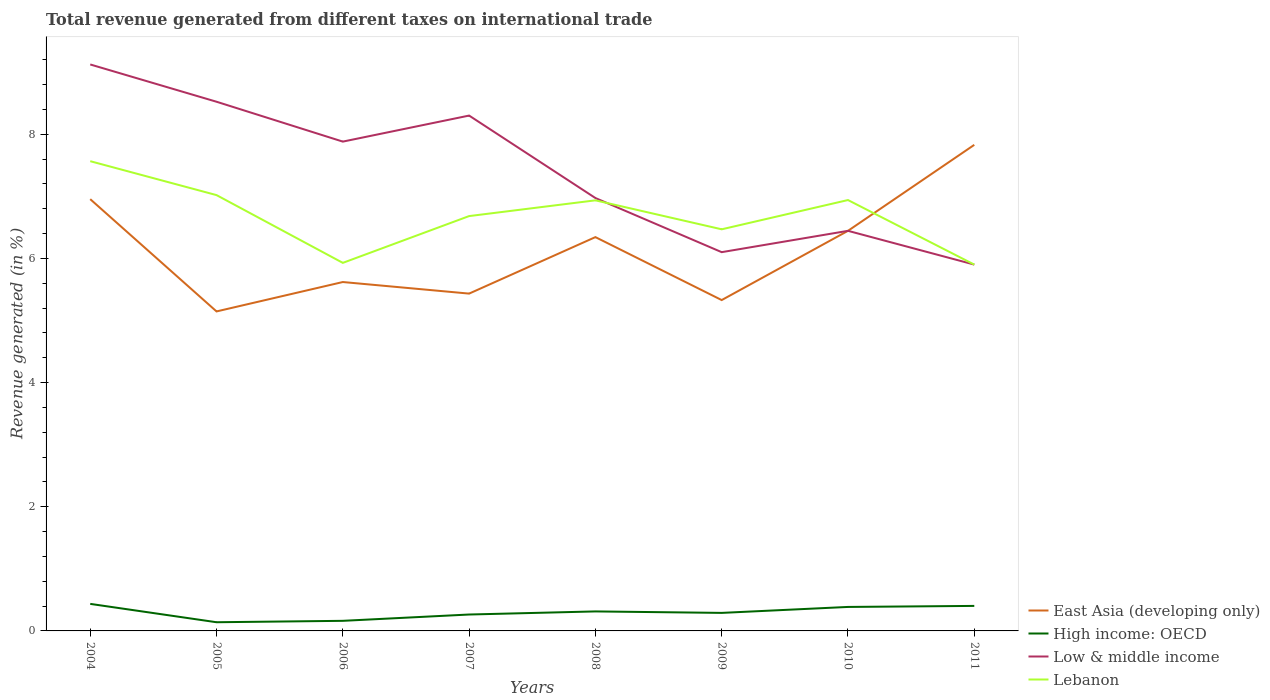How many different coloured lines are there?
Provide a succinct answer. 4. Does the line corresponding to East Asia (developing only) intersect with the line corresponding to Lebanon?
Provide a succinct answer. Yes. Is the number of lines equal to the number of legend labels?
Your response must be concise. Yes. Across all years, what is the maximum total revenue generated in High income: OECD?
Offer a very short reply. 0.14. In which year was the total revenue generated in Lebanon maximum?
Give a very brief answer. 2011. What is the total total revenue generated in Low & middle income in the graph?
Ensure brevity in your answer.  1.78. What is the difference between the highest and the second highest total revenue generated in Low & middle income?
Give a very brief answer. 3.22. What is the difference between the highest and the lowest total revenue generated in Low & middle income?
Keep it short and to the point. 4. Is the total revenue generated in Lebanon strictly greater than the total revenue generated in Low & middle income over the years?
Provide a succinct answer. No. What is the difference between two consecutive major ticks on the Y-axis?
Your answer should be compact. 2. Are the values on the major ticks of Y-axis written in scientific E-notation?
Give a very brief answer. No. Does the graph contain any zero values?
Offer a terse response. No. Does the graph contain grids?
Give a very brief answer. No. How many legend labels are there?
Your answer should be very brief. 4. What is the title of the graph?
Keep it short and to the point. Total revenue generated from different taxes on international trade. Does "Saudi Arabia" appear as one of the legend labels in the graph?
Give a very brief answer. No. What is the label or title of the X-axis?
Provide a short and direct response. Years. What is the label or title of the Y-axis?
Provide a succinct answer. Revenue generated (in %). What is the Revenue generated (in %) of East Asia (developing only) in 2004?
Offer a very short reply. 6.95. What is the Revenue generated (in %) of High income: OECD in 2004?
Ensure brevity in your answer.  0.44. What is the Revenue generated (in %) of Low & middle income in 2004?
Provide a succinct answer. 9.12. What is the Revenue generated (in %) in Lebanon in 2004?
Give a very brief answer. 7.57. What is the Revenue generated (in %) in East Asia (developing only) in 2005?
Provide a succinct answer. 5.15. What is the Revenue generated (in %) in High income: OECD in 2005?
Offer a very short reply. 0.14. What is the Revenue generated (in %) of Low & middle income in 2005?
Your response must be concise. 8.52. What is the Revenue generated (in %) of Lebanon in 2005?
Ensure brevity in your answer.  7.02. What is the Revenue generated (in %) of East Asia (developing only) in 2006?
Offer a terse response. 5.62. What is the Revenue generated (in %) in High income: OECD in 2006?
Give a very brief answer. 0.16. What is the Revenue generated (in %) in Low & middle income in 2006?
Keep it short and to the point. 7.88. What is the Revenue generated (in %) in Lebanon in 2006?
Offer a terse response. 5.93. What is the Revenue generated (in %) in East Asia (developing only) in 2007?
Offer a very short reply. 5.43. What is the Revenue generated (in %) of High income: OECD in 2007?
Offer a terse response. 0.26. What is the Revenue generated (in %) in Low & middle income in 2007?
Your answer should be compact. 8.3. What is the Revenue generated (in %) of Lebanon in 2007?
Keep it short and to the point. 6.68. What is the Revenue generated (in %) in East Asia (developing only) in 2008?
Your answer should be very brief. 6.34. What is the Revenue generated (in %) of High income: OECD in 2008?
Your response must be concise. 0.31. What is the Revenue generated (in %) in Low & middle income in 2008?
Provide a short and direct response. 6.97. What is the Revenue generated (in %) of Lebanon in 2008?
Ensure brevity in your answer.  6.93. What is the Revenue generated (in %) in East Asia (developing only) in 2009?
Ensure brevity in your answer.  5.33. What is the Revenue generated (in %) of High income: OECD in 2009?
Offer a very short reply. 0.29. What is the Revenue generated (in %) of Low & middle income in 2009?
Make the answer very short. 6.1. What is the Revenue generated (in %) in Lebanon in 2009?
Provide a succinct answer. 6.47. What is the Revenue generated (in %) of East Asia (developing only) in 2010?
Your answer should be compact. 6.44. What is the Revenue generated (in %) of High income: OECD in 2010?
Provide a succinct answer. 0.39. What is the Revenue generated (in %) in Low & middle income in 2010?
Offer a very short reply. 6.44. What is the Revenue generated (in %) of Lebanon in 2010?
Offer a terse response. 6.94. What is the Revenue generated (in %) in East Asia (developing only) in 2011?
Make the answer very short. 7.83. What is the Revenue generated (in %) in High income: OECD in 2011?
Offer a very short reply. 0.4. What is the Revenue generated (in %) in Low & middle income in 2011?
Your answer should be very brief. 5.9. What is the Revenue generated (in %) in Lebanon in 2011?
Provide a short and direct response. 5.9. Across all years, what is the maximum Revenue generated (in %) of East Asia (developing only)?
Your response must be concise. 7.83. Across all years, what is the maximum Revenue generated (in %) in High income: OECD?
Make the answer very short. 0.44. Across all years, what is the maximum Revenue generated (in %) in Low & middle income?
Your answer should be compact. 9.12. Across all years, what is the maximum Revenue generated (in %) in Lebanon?
Your response must be concise. 7.57. Across all years, what is the minimum Revenue generated (in %) of East Asia (developing only)?
Keep it short and to the point. 5.15. Across all years, what is the minimum Revenue generated (in %) in High income: OECD?
Ensure brevity in your answer.  0.14. Across all years, what is the minimum Revenue generated (in %) in Low & middle income?
Provide a succinct answer. 5.9. Across all years, what is the minimum Revenue generated (in %) of Lebanon?
Give a very brief answer. 5.9. What is the total Revenue generated (in %) in East Asia (developing only) in the graph?
Make the answer very short. 49.09. What is the total Revenue generated (in %) in High income: OECD in the graph?
Ensure brevity in your answer.  2.4. What is the total Revenue generated (in %) in Low & middle income in the graph?
Keep it short and to the point. 59.24. What is the total Revenue generated (in %) of Lebanon in the graph?
Give a very brief answer. 53.44. What is the difference between the Revenue generated (in %) of East Asia (developing only) in 2004 and that in 2005?
Give a very brief answer. 1.81. What is the difference between the Revenue generated (in %) in High income: OECD in 2004 and that in 2005?
Ensure brevity in your answer.  0.3. What is the difference between the Revenue generated (in %) of Low & middle income in 2004 and that in 2005?
Keep it short and to the point. 0.6. What is the difference between the Revenue generated (in %) of Lebanon in 2004 and that in 2005?
Offer a terse response. 0.55. What is the difference between the Revenue generated (in %) of East Asia (developing only) in 2004 and that in 2006?
Your answer should be very brief. 1.33. What is the difference between the Revenue generated (in %) of High income: OECD in 2004 and that in 2006?
Ensure brevity in your answer.  0.27. What is the difference between the Revenue generated (in %) of Low & middle income in 2004 and that in 2006?
Offer a very short reply. 1.24. What is the difference between the Revenue generated (in %) of Lebanon in 2004 and that in 2006?
Keep it short and to the point. 1.64. What is the difference between the Revenue generated (in %) in East Asia (developing only) in 2004 and that in 2007?
Provide a succinct answer. 1.52. What is the difference between the Revenue generated (in %) of High income: OECD in 2004 and that in 2007?
Provide a short and direct response. 0.17. What is the difference between the Revenue generated (in %) in Low & middle income in 2004 and that in 2007?
Your answer should be very brief. 0.82. What is the difference between the Revenue generated (in %) in Lebanon in 2004 and that in 2007?
Your response must be concise. 0.88. What is the difference between the Revenue generated (in %) of East Asia (developing only) in 2004 and that in 2008?
Ensure brevity in your answer.  0.61. What is the difference between the Revenue generated (in %) in High income: OECD in 2004 and that in 2008?
Keep it short and to the point. 0.12. What is the difference between the Revenue generated (in %) in Low & middle income in 2004 and that in 2008?
Give a very brief answer. 2.15. What is the difference between the Revenue generated (in %) of Lebanon in 2004 and that in 2008?
Your answer should be very brief. 0.63. What is the difference between the Revenue generated (in %) in East Asia (developing only) in 2004 and that in 2009?
Give a very brief answer. 1.63. What is the difference between the Revenue generated (in %) of High income: OECD in 2004 and that in 2009?
Provide a short and direct response. 0.15. What is the difference between the Revenue generated (in %) of Low & middle income in 2004 and that in 2009?
Your answer should be very brief. 3.02. What is the difference between the Revenue generated (in %) of Lebanon in 2004 and that in 2009?
Provide a succinct answer. 1.1. What is the difference between the Revenue generated (in %) in East Asia (developing only) in 2004 and that in 2010?
Your response must be concise. 0.51. What is the difference between the Revenue generated (in %) of High income: OECD in 2004 and that in 2010?
Provide a succinct answer. 0.05. What is the difference between the Revenue generated (in %) in Low & middle income in 2004 and that in 2010?
Offer a very short reply. 2.68. What is the difference between the Revenue generated (in %) in Lebanon in 2004 and that in 2010?
Your answer should be compact. 0.63. What is the difference between the Revenue generated (in %) in East Asia (developing only) in 2004 and that in 2011?
Offer a terse response. -0.87. What is the difference between the Revenue generated (in %) of High income: OECD in 2004 and that in 2011?
Your answer should be compact. 0.03. What is the difference between the Revenue generated (in %) of Low & middle income in 2004 and that in 2011?
Your answer should be compact. 3.22. What is the difference between the Revenue generated (in %) in Lebanon in 2004 and that in 2011?
Your answer should be very brief. 1.67. What is the difference between the Revenue generated (in %) of East Asia (developing only) in 2005 and that in 2006?
Your response must be concise. -0.47. What is the difference between the Revenue generated (in %) of High income: OECD in 2005 and that in 2006?
Provide a succinct answer. -0.02. What is the difference between the Revenue generated (in %) of Low & middle income in 2005 and that in 2006?
Make the answer very short. 0.64. What is the difference between the Revenue generated (in %) in Lebanon in 2005 and that in 2006?
Give a very brief answer. 1.09. What is the difference between the Revenue generated (in %) of East Asia (developing only) in 2005 and that in 2007?
Offer a terse response. -0.29. What is the difference between the Revenue generated (in %) in High income: OECD in 2005 and that in 2007?
Keep it short and to the point. -0.12. What is the difference between the Revenue generated (in %) in Low & middle income in 2005 and that in 2007?
Ensure brevity in your answer.  0.22. What is the difference between the Revenue generated (in %) in Lebanon in 2005 and that in 2007?
Offer a very short reply. 0.34. What is the difference between the Revenue generated (in %) in East Asia (developing only) in 2005 and that in 2008?
Make the answer very short. -1.2. What is the difference between the Revenue generated (in %) of High income: OECD in 2005 and that in 2008?
Offer a terse response. -0.17. What is the difference between the Revenue generated (in %) of Low & middle income in 2005 and that in 2008?
Offer a very short reply. 1.55. What is the difference between the Revenue generated (in %) of Lebanon in 2005 and that in 2008?
Give a very brief answer. 0.08. What is the difference between the Revenue generated (in %) of East Asia (developing only) in 2005 and that in 2009?
Ensure brevity in your answer.  -0.18. What is the difference between the Revenue generated (in %) of High income: OECD in 2005 and that in 2009?
Ensure brevity in your answer.  -0.15. What is the difference between the Revenue generated (in %) of Low & middle income in 2005 and that in 2009?
Give a very brief answer. 2.42. What is the difference between the Revenue generated (in %) of Lebanon in 2005 and that in 2009?
Offer a very short reply. 0.55. What is the difference between the Revenue generated (in %) in East Asia (developing only) in 2005 and that in 2010?
Provide a short and direct response. -1.3. What is the difference between the Revenue generated (in %) of High income: OECD in 2005 and that in 2010?
Keep it short and to the point. -0.25. What is the difference between the Revenue generated (in %) of Low & middle income in 2005 and that in 2010?
Your answer should be compact. 2.08. What is the difference between the Revenue generated (in %) of Lebanon in 2005 and that in 2010?
Provide a succinct answer. 0.08. What is the difference between the Revenue generated (in %) in East Asia (developing only) in 2005 and that in 2011?
Ensure brevity in your answer.  -2.68. What is the difference between the Revenue generated (in %) in High income: OECD in 2005 and that in 2011?
Keep it short and to the point. -0.26. What is the difference between the Revenue generated (in %) in Low & middle income in 2005 and that in 2011?
Provide a succinct answer. 2.62. What is the difference between the Revenue generated (in %) in Lebanon in 2005 and that in 2011?
Give a very brief answer. 1.12. What is the difference between the Revenue generated (in %) of East Asia (developing only) in 2006 and that in 2007?
Give a very brief answer. 0.19. What is the difference between the Revenue generated (in %) in High income: OECD in 2006 and that in 2007?
Give a very brief answer. -0.1. What is the difference between the Revenue generated (in %) of Low & middle income in 2006 and that in 2007?
Offer a very short reply. -0.42. What is the difference between the Revenue generated (in %) in Lebanon in 2006 and that in 2007?
Provide a short and direct response. -0.75. What is the difference between the Revenue generated (in %) in East Asia (developing only) in 2006 and that in 2008?
Ensure brevity in your answer.  -0.72. What is the difference between the Revenue generated (in %) in High income: OECD in 2006 and that in 2008?
Offer a very short reply. -0.15. What is the difference between the Revenue generated (in %) in Low & middle income in 2006 and that in 2008?
Keep it short and to the point. 0.91. What is the difference between the Revenue generated (in %) of Lebanon in 2006 and that in 2008?
Keep it short and to the point. -1.01. What is the difference between the Revenue generated (in %) of East Asia (developing only) in 2006 and that in 2009?
Your answer should be compact. 0.29. What is the difference between the Revenue generated (in %) in High income: OECD in 2006 and that in 2009?
Ensure brevity in your answer.  -0.13. What is the difference between the Revenue generated (in %) of Low & middle income in 2006 and that in 2009?
Your answer should be compact. 1.78. What is the difference between the Revenue generated (in %) of Lebanon in 2006 and that in 2009?
Give a very brief answer. -0.54. What is the difference between the Revenue generated (in %) in East Asia (developing only) in 2006 and that in 2010?
Ensure brevity in your answer.  -0.82. What is the difference between the Revenue generated (in %) in High income: OECD in 2006 and that in 2010?
Offer a very short reply. -0.22. What is the difference between the Revenue generated (in %) of Low & middle income in 2006 and that in 2010?
Your answer should be very brief. 1.44. What is the difference between the Revenue generated (in %) in Lebanon in 2006 and that in 2010?
Your answer should be very brief. -1.01. What is the difference between the Revenue generated (in %) in East Asia (developing only) in 2006 and that in 2011?
Your response must be concise. -2.21. What is the difference between the Revenue generated (in %) of High income: OECD in 2006 and that in 2011?
Keep it short and to the point. -0.24. What is the difference between the Revenue generated (in %) in Low & middle income in 2006 and that in 2011?
Your response must be concise. 1.98. What is the difference between the Revenue generated (in %) of Lebanon in 2006 and that in 2011?
Offer a very short reply. 0.03. What is the difference between the Revenue generated (in %) in East Asia (developing only) in 2007 and that in 2008?
Your response must be concise. -0.91. What is the difference between the Revenue generated (in %) of High income: OECD in 2007 and that in 2008?
Your answer should be very brief. -0.05. What is the difference between the Revenue generated (in %) of Low & middle income in 2007 and that in 2008?
Your answer should be compact. 1.33. What is the difference between the Revenue generated (in %) of Lebanon in 2007 and that in 2008?
Offer a very short reply. -0.25. What is the difference between the Revenue generated (in %) in East Asia (developing only) in 2007 and that in 2009?
Give a very brief answer. 0.1. What is the difference between the Revenue generated (in %) of High income: OECD in 2007 and that in 2009?
Provide a succinct answer. -0.03. What is the difference between the Revenue generated (in %) in Lebanon in 2007 and that in 2009?
Your response must be concise. 0.21. What is the difference between the Revenue generated (in %) in East Asia (developing only) in 2007 and that in 2010?
Offer a terse response. -1.01. What is the difference between the Revenue generated (in %) in High income: OECD in 2007 and that in 2010?
Provide a succinct answer. -0.12. What is the difference between the Revenue generated (in %) of Low & middle income in 2007 and that in 2010?
Offer a terse response. 1.86. What is the difference between the Revenue generated (in %) of Lebanon in 2007 and that in 2010?
Ensure brevity in your answer.  -0.26. What is the difference between the Revenue generated (in %) of East Asia (developing only) in 2007 and that in 2011?
Offer a terse response. -2.4. What is the difference between the Revenue generated (in %) in High income: OECD in 2007 and that in 2011?
Provide a succinct answer. -0.14. What is the difference between the Revenue generated (in %) in Low & middle income in 2007 and that in 2011?
Ensure brevity in your answer.  2.4. What is the difference between the Revenue generated (in %) of Lebanon in 2007 and that in 2011?
Offer a terse response. 0.78. What is the difference between the Revenue generated (in %) in High income: OECD in 2008 and that in 2009?
Your answer should be compact. 0.02. What is the difference between the Revenue generated (in %) in Low & middle income in 2008 and that in 2009?
Offer a very short reply. 0.87. What is the difference between the Revenue generated (in %) in Lebanon in 2008 and that in 2009?
Give a very brief answer. 0.47. What is the difference between the Revenue generated (in %) of East Asia (developing only) in 2008 and that in 2010?
Offer a terse response. -0.1. What is the difference between the Revenue generated (in %) of High income: OECD in 2008 and that in 2010?
Give a very brief answer. -0.07. What is the difference between the Revenue generated (in %) in Low & middle income in 2008 and that in 2010?
Keep it short and to the point. 0.53. What is the difference between the Revenue generated (in %) in Lebanon in 2008 and that in 2010?
Make the answer very short. -0. What is the difference between the Revenue generated (in %) in East Asia (developing only) in 2008 and that in 2011?
Your response must be concise. -1.49. What is the difference between the Revenue generated (in %) of High income: OECD in 2008 and that in 2011?
Your response must be concise. -0.09. What is the difference between the Revenue generated (in %) in Low & middle income in 2008 and that in 2011?
Provide a short and direct response. 1.07. What is the difference between the Revenue generated (in %) in Lebanon in 2008 and that in 2011?
Provide a succinct answer. 1.03. What is the difference between the Revenue generated (in %) of East Asia (developing only) in 2009 and that in 2010?
Make the answer very short. -1.12. What is the difference between the Revenue generated (in %) in High income: OECD in 2009 and that in 2010?
Provide a succinct answer. -0.1. What is the difference between the Revenue generated (in %) of Low & middle income in 2009 and that in 2010?
Your answer should be compact. -0.34. What is the difference between the Revenue generated (in %) in Lebanon in 2009 and that in 2010?
Ensure brevity in your answer.  -0.47. What is the difference between the Revenue generated (in %) in High income: OECD in 2009 and that in 2011?
Your answer should be compact. -0.11. What is the difference between the Revenue generated (in %) of Low & middle income in 2009 and that in 2011?
Your answer should be compact. 0.2. What is the difference between the Revenue generated (in %) in Lebanon in 2009 and that in 2011?
Your answer should be very brief. 0.57. What is the difference between the Revenue generated (in %) in East Asia (developing only) in 2010 and that in 2011?
Give a very brief answer. -1.38. What is the difference between the Revenue generated (in %) of High income: OECD in 2010 and that in 2011?
Give a very brief answer. -0.02. What is the difference between the Revenue generated (in %) in Low & middle income in 2010 and that in 2011?
Give a very brief answer. 0.54. What is the difference between the Revenue generated (in %) in Lebanon in 2010 and that in 2011?
Your answer should be very brief. 1.04. What is the difference between the Revenue generated (in %) in East Asia (developing only) in 2004 and the Revenue generated (in %) in High income: OECD in 2005?
Make the answer very short. 6.81. What is the difference between the Revenue generated (in %) of East Asia (developing only) in 2004 and the Revenue generated (in %) of Low & middle income in 2005?
Ensure brevity in your answer.  -1.57. What is the difference between the Revenue generated (in %) in East Asia (developing only) in 2004 and the Revenue generated (in %) in Lebanon in 2005?
Make the answer very short. -0.07. What is the difference between the Revenue generated (in %) of High income: OECD in 2004 and the Revenue generated (in %) of Low & middle income in 2005?
Your response must be concise. -8.09. What is the difference between the Revenue generated (in %) of High income: OECD in 2004 and the Revenue generated (in %) of Lebanon in 2005?
Offer a terse response. -6.58. What is the difference between the Revenue generated (in %) in Low & middle income in 2004 and the Revenue generated (in %) in Lebanon in 2005?
Your response must be concise. 2.1. What is the difference between the Revenue generated (in %) in East Asia (developing only) in 2004 and the Revenue generated (in %) in High income: OECD in 2006?
Provide a short and direct response. 6.79. What is the difference between the Revenue generated (in %) in East Asia (developing only) in 2004 and the Revenue generated (in %) in Low & middle income in 2006?
Your answer should be very brief. -0.93. What is the difference between the Revenue generated (in %) in East Asia (developing only) in 2004 and the Revenue generated (in %) in Lebanon in 2006?
Provide a short and direct response. 1.03. What is the difference between the Revenue generated (in %) in High income: OECD in 2004 and the Revenue generated (in %) in Low & middle income in 2006?
Offer a very short reply. -7.45. What is the difference between the Revenue generated (in %) of High income: OECD in 2004 and the Revenue generated (in %) of Lebanon in 2006?
Ensure brevity in your answer.  -5.49. What is the difference between the Revenue generated (in %) in Low & middle income in 2004 and the Revenue generated (in %) in Lebanon in 2006?
Your answer should be very brief. 3.2. What is the difference between the Revenue generated (in %) in East Asia (developing only) in 2004 and the Revenue generated (in %) in High income: OECD in 2007?
Provide a short and direct response. 6.69. What is the difference between the Revenue generated (in %) in East Asia (developing only) in 2004 and the Revenue generated (in %) in Low & middle income in 2007?
Provide a succinct answer. -1.35. What is the difference between the Revenue generated (in %) in East Asia (developing only) in 2004 and the Revenue generated (in %) in Lebanon in 2007?
Provide a short and direct response. 0.27. What is the difference between the Revenue generated (in %) of High income: OECD in 2004 and the Revenue generated (in %) of Low & middle income in 2007?
Give a very brief answer. -7.86. What is the difference between the Revenue generated (in %) in High income: OECD in 2004 and the Revenue generated (in %) in Lebanon in 2007?
Your answer should be compact. -6.25. What is the difference between the Revenue generated (in %) of Low & middle income in 2004 and the Revenue generated (in %) of Lebanon in 2007?
Your answer should be very brief. 2.44. What is the difference between the Revenue generated (in %) of East Asia (developing only) in 2004 and the Revenue generated (in %) of High income: OECD in 2008?
Provide a short and direct response. 6.64. What is the difference between the Revenue generated (in %) of East Asia (developing only) in 2004 and the Revenue generated (in %) of Low & middle income in 2008?
Make the answer very short. -0.02. What is the difference between the Revenue generated (in %) of East Asia (developing only) in 2004 and the Revenue generated (in %) of Lebanon in 2008?
Your answer should be compact. 0.02. What is the difference between the Revenue generated (in %) of High income: OECD in 2004 and the Revenue generated (in %) of Low & middle income in 2008?
Keep it short and to the point. -6.54. What is the difference between the Revenue generated (in %) of High income: OECD in 2004 and the Revenue generated (in %) of Lebanon in 2008?
Give a very brief answer. -6.5. What is the difference between the Revenue generated (in %) of Low & middle income in 2004 and the Revenue generated (in %) of Lebanon in 2008?
Ensure brevity in your answer.  2.19. What is the difference between the Revenue generated (in %) of East Asia (developing only) in 2004 and the Revenue generated (in %) of High income: OECD in 2009?
Your answer should be compact. 6.66. What is the difference between the Revenue generated (in %) in East Asia (developing only) in 2004 and the Revenue generated (in %) in Low & middle income in 2009?
Provide a short and direct response. 0.85. What is the difference between the Revenue generated (in %) in East Asia (developing only) in 2004 and the Revenue generated (in %) in Lebanon in 2009?
Your answer should be compact. 0.49. What is the difference between the Revenue generated (in %) of High income: OECD in 2004 and the Revenue generated (in %) of Low & middle income in 2009?
Your response must be concise. -5.66. What is the difference between the Revenue generated (in %) in High income: OECD in 2004 and the Revenue generated (in %) in Lebanon in 2009?
Ensure brevity in your answer.  -6.03. What is the difference between the Revenue generated (in %) of Low & middle income in 2004 and the Revenue generated (in %) of Lebanon in 2009?
Offer a terse response. 2.65. What is the difference between the Revenue generated (in %) of East Asia (developing only) in 2004 and the Revenue generated (in %) of High income: OECD in 2010?
Ensure brevity in your answer.  6.57. What is the difference between the Revenue generated (in %) of East Asia (developing only) in 2004 and the Revenue generated (in %) of Low & middle income in 2010?
Ensure brevity in your answer.  0.51. What is the difference between the Revenue generated (in %) of East Asia (developing only) in 2004 and the Revenue generated (in %) of Lebanon in 2010?
Give a very brief answer. 0.01. What is the difference between the Revenue generated (in %) of High income: OECD in 2004 and the Revenue generated (in %) of Low & middle income in 2010?
Provide a succinct answer. -6.01. What is the difference between the Revenue generated (in %) in High income: OECD in 2004 and the Revenue generated (in %) in Lebanon in 2010?
Give a very brief answer. -6.5. What is the difference between the Revenue generated (in %) of Low & middle income in 2004 and the Revenue generated (in %) of Lebanon in 2010?
Keep it short and to the point. 2.18. What is the difference between the Revenue generated (in %) in East Asia (developing only) in 2004 and the Revenue generated (in %) in High income: OECD in 2011?
Offer a terse response. 6.55. What is the difference between the Revenue generated (in %) in East Asia (developing only) in 2004 and the Revenue generated (in %) in Low & middle income in 2011?
Offer a terse response. 1.05. What is the difference between the Revenue generated (in %) in East Asia (developing only) in 2004 and the Revenue generated (in %) in Lebanon in 2011?
Ensure brevity in your answer.  1.05. What is the difference between the Revenue generated (in %) in High income: OECD in 2004 and the Revenue generated (in %) in Low & middle income in 2011?
Provide a succinct answer. -5.46. What is the difference between the Revenue generated (in %) of High income: OECD in 2004 and the Revenue generated (in %) of Lebanon in 2011?
Keep it short and to the point. -5.46. What is the difference between the Revenue generated (in %) of Low & middle income in 2004 and the Revenue generated (in %) of Lebanon in 2011?
Offer a very short reply. 3.22. What is the difference between the Revenue generated (in %) in East Asia (developing only) in 2005 and the Revenue generated (in %) in High income: OECD in 2006?
Provide a short and direct response. 4.98. What is the difference between the Revenue generated (in %) in East Asia (developing only) in 2005 and the Revenue generated (in %) in Low & middle income in 2006?
Provide a short and direct response. -2.73. What is the difference between the Revenue generated (in %) in East Asia (developing only) in 2005 and the Revenue generated (in %) in Lebanon in 2006?
Keep it short and to the point. -0.78. What is the difference between the Revenue generated (in %) of High income: OECD in 2005 and the Revenue generated (in %) of Low & middle income in 2006?
Offer a very short reply. -7.74. What is the difference between the Revenue generated (in %) of High income: OECD in 2005 and the Revenue generated (in %) of Lebanon in 2006?
Make the answer very short. -5.79. What is the difference between the Revenue generated (in %) in Low & middle income in 2005 and the Revenue generated (in %) in Lebanon in 2006?
Provide a succinct answer. 2.6. What is the difference between the Revenue generated (in %) in East Asia (developing only) in 2005 and the Revenue generated (in %) in High income: OECD in 2007?
Your answer should be very brief. 4.88. What is the difference between the Revenue generated (in %) in East Asia (developing only) in 2005 and the Revenue generated (in %) in Low & middle income in 2007?
Offer a terse response. -3.15. What is the difference between the Revenue generated (in %) of East Asia (developing only) in 2005 and the Revenue generated (in %) of Lebanon in 2007?
Give a very brief answer. -1.54. What is the difference between the Revenue generated (in %) of High income: OECD in 2005 and the Revenue generated (in %) of Low & middle income in 2007?
Offer a very short reply. -8.16. What is the difference between the Revenue generated (in %) in High income: OECD in 2005 and the Revenue generated (in %) in Lebanon in 2007?
Keep it short and to the point. -6.54. What is the difference between the Revenue generated (in %) in Low & middle income in 2005 and the Revenue generated (in %) in Lebanon in 2007?
Provide a short and direct response. 1.84. What is the difference between the Revenue generated (in %) in East Asia (developing only) in 2005 and the Revenue generated (in %) in High income: OECD in 2008?
Make the answer very short. 4.83. What is the difference between the Revenue generated (in %) of East Asia (developing only) in 2005 and the Revenue generated (in %) of Low & middle income in 2008?
Ensure brevity in your answer.  -1.83. What is the difference between the Revenue generated (in %) of East Asia (developing only) in 2005 and the Revenue generated (in %) of Lebanon in 2008?
Give a very brief answer. -1.79. What is the difference between the Revenue generated (in %) of High income: OECD in 2005 and the Revenue generated (in %) of Low & middle income in 2008?
Your response must be concise. -6.83. What is the difference between the Revenue generated (in %) in High income: OECD in 2005 and the Revenue generated (in %) in Lebanon in 2008?
Give a very brief answer. -6.79. What is the difference between the Revenue generated (in %) of Low & middle income in 2005 and the Revenue generated (in %) of Lebanon in 2008?
Make the answer very short. 1.59. What is the difference between the Revenue generated (in %) in East Asia (developing only) in 2005 and the Revenue generated (in %) in High income: OECD in 2009?
Your answer should be very brief. 4.86. What is the difference between the Revenue generated (in %) in East Asia (developing only) in 2005 and the Revenue generated (in %) in Low & middle income in 2009?
Keep it short and to the point. -0.95. What is the difference between the Revenue generated (in %) of East Asia (developing only) in 2005 and the Revenue generated (in %) of Lebanon in 2009?
Your answer should be very brief. -1.32. What is the difference between the Revenue generated (in %) of High income: OECD in 2005 and the Revenue generated (in %) of Low & middle income in 2009?
Give a very brief answer. -5.96. What is the difference between the Revenue generated (in %) in High income: OECD in 2005 and the Revenue generated (in %) in Lebanon in 2009?
Provide a short and direct response. -6.33. What is the difference between the Revenue generated (in %) of Low & middle income in 2005 and the Revenue generated (in %) of Lebanon in 2009?
Ensure brevity in your answer.  2.05. What is the difference between the Revenue generated (in %) in East Asia (developing only) in 2005 and the Revenue generated (in %) in High income: OECD in 2010?
Your answer should be very brief. 4.76. What is the difference between the Revenue generated (in %) of East Asia (developing only) in 2005 and the Revenue generated (in %) of Low & middle income in 2010?
Your response must be concise. -1.3. What is the difference between the Revenue generated (in %) in East Asia (developing only) in 2005 and the Revenue generated (in %) in Lebanon in 2010?
Give a very brief answer. -1.79. What is the difference between the Revenue generated (in %) of High income: OECD in 2005 and the Revenue generated (in %) of Low & middle income in 2010?
Keep it short and to the point. -6.3. What is the difference between the Revenue generated (in %) of High income: OECD in 2005 and the Revenue generated (in %) of Lebanon in 2010?
Keep it short and to the point. -6.8. What is the difference between the Revenue generated (in %) of Low & middle income in 2005 and the Revenue generated (in %) of Lebanon in 2010?
Keep it short and to the point. 1.58. What is the difference between the Revenue generated (in %) of East Asia (developing only) in 2005 and the Revenue generated (in %) of High income: OECD in 2011?
Keep it short and to the point. 4.74. What is the difference between the Revenue generated (in %) in East Asia (developing only) in 2005 and the Revenue generated (in %) in Low & middle income in 2011?
Ensure brevity in your answer.  -0.75. What is the difference between the Revenue generated (in %) of East Asia (developing only) in 2005 and the Revenue generated (in %) of Lebanon in 2011?
Provide a short and direct response. -0.75. What is the difference between the Revenue generated (in %) of High income: OECD in 2005 and the Revenue generated (in %) of Low & middle income in 2011?
Make the answer very short. -5.76. What is the difference between the Revenue generated (in %) of High income: OECD in 2005 and the Revenue generated (in %) of Lebanon in 2011?
Your answer should be very brief. -5.76. What is the difference between the Revenue generated (in %) of Low & middle income in 2005 and the Revenue generated (in %) of Lebanon in 2011?
Ensure brevity in your answer.  2.62. What is the difference between the Revenue generated (in %) of East Asia (developing only) in 2006 and the Revenue generated (in %) of High income: OECD in 2007?
Keep it short and to the point. 5.36. What is the difference between the Revenue generated (in %) in East Asia (developing only) in 2006 and the Revenue generated (in %) in Low & middle income in 2007?
Give a very brief answer. -2.68. What is the difference between the Revenue generated (in %) of East Asia (developing only) in 2006 and the Revenue generated (in %) of Lebanon in 2007?
Offer a very short reply. -1.06. What is the difference between the Revenue generated (in %) in High income: OECD in 2006 and the Revenue generated (in %) in Low & middle income in 2007?
Your answer should be very brief. -8.14. What is the difference between the Revenue generated (in %) of High income: OECD in 2006 and the Revenue generated (in %) of Lebanon in 2007?
Ensure brevity in your answer.  -6.52. What is the difference between the Revenue generated (in %) in Low & middle income in 2006 and the Revenue generated (in %) in Lebanon in 2007?
Make the answer very short. 1.2. What is the difference between the Revenue generated (in %) of East Asia (developing only) in 2006 and the Revenue generated (in %) of High income: OECD in 2008?
Provide a short and direct response. 5.31. What is the difference between the Revenue generated (in %) in East Asia (developing only) in 2006 and the Revenue generated (in %) in Low & middle income in 2008?
Ensure brevity in your answer.  -1.35. What is the difference between the Revenue generated (in %) of East Asia (developing only) in 2006 and the Revenue generated (in %) of Lebanon in 2008?
Your answer should be compact. -1.32. What is the difference between the Revenue generated (in %) of High income: OECD in 2006 and the Revenue generated (in %) of Low & middle income in 2008?
Provide a succinct answer. -6.81. What is the difference between the Revenue generated (in %) in High income: OECD in 2006 and the Revenue generated (in %) in Lebanon in 2008?
Offer a terse response. -6.77. What is the difference between the Revenue generated (in %) in Low & middle income in 2006 and the Revenue generated (in %) in Lebanon in 2008?
Your response must be concise. 0.95. What is the difference between the Revenue generated (in %) in East Asia (developing only) in 2006 and the Revenue generated (in %) in High income: OECD in 2009?
Keep it short and to the point. 5.33. What is the difference between the Revenue generated (in %) of East Asia (developing only) in 2006 and the Revenue generated (in %) of Low & middle income in 2009?
Offer a terse response. -0.48. What is the difference between the Revenue generated (in %) of East Asia (developing only) in 2006 and the Revenue generated (in %) of Lebanon in 2009?
Keep it short and to the point. -0.85. What is the difference between the Revenue generated (in %) of High income: OECD in 2006 and the Revenue generated (in %) of Low & middle income in 2009?
Offer a very short reply. -5.94. What is the difference between the Revenue generated (in %) of High income: OECD in 2006 and the Revenue generated (in %) of Lebanon in 2009?
Provide a succinct answer. -6.31. What is the difference between the Revenue generated (in %) in Low & middle income in 2006 and the Revenue generated (in %) in Lebanon in 2009?
Offer a terse response. 1.41. What is the difference between the Revenue generated (in %) of East Asia (developing only) in 2006 and the Revenue generated (in %) of High income: OECD in 2010?
Keep it short and to the point. 5.23. What is the difference between the Revenue generated (in %) of East Asia (developing only) in 2006 and the Revenue generated (in %) of Low & middle income in 2010?
Ensure brevity in your answer.  -0.82. What is the difference between the Revenue generated (in %) of East Asia (developing only) in 2006 and the Revenue generated (in %) of Lebanon in 2010?
Your answer should be very brief. -1.32. What is the difference between the Revenue generated (in %) of High income: OECD in 2006 and the Revenue generated (in %) of Low & middle income in 2010?
Provide a succinct answer. -6.28. What is the difference between the Revenue generated (in %) of High income: OECD in 2006 and the Revenue generated (in %) of Lebanon in 2010?
Your answer should be compact. -6.78. What is the difference between the Revenue generated (in %) of Low & middle income in 2006 and the Revenue generated (in %) of Lebanon in 2010?
Offer a terse response. 0.94. What is the difference between the Revenue generated (in %) in East Asia (developing only) in 2006 and the Revenue generated (in %) in High income: OECD in 2011?
Your response must be concise. 5.22. What is the difference between the Revenue generated (in %) in East Asia (developing only) in 2006 and the Revenue generated (in %) in Low & middle income in 2011?
Your answer should be compact. -0.28. What is the difference between the Revenue generated (in %) of East Asia (developing only) in 2006 and the Revenue generated (in %) of Lebanon in 2011?
Keep it short and to the point. -0.28. What is the difference between the Revenue generated (in %) in High income: OECD in 2006 and the Revenue generated (in %) in Low & middle income in 2011?
Give a very brief answer. -5.74. What is the difference between the Revenue generated (in %) in High income: OECD in 2006 and the Revenue generated (in %) in Lebanon in 2011?
Keep it short and to the point. -5.74. What is the difference between the Revenue generated (in %) in Low & middle income in 2006 and the Revenue generated (in %) in Lebanon in 2011?
Give a very brief answer. 1.98. What is the difference between the Revenue generated (in %) of East Asia (developing only) in 2007 and the Revenue generated (in %) of High income: OECD in 2008?
Your answer should be compact. 5.12. What is the difference between the Revenue generated (in %) in East Asia (developing only) in 2007 and the Revenue generated (in %) in Low & middle income in 2008?
Provide a succinct answer. -1.54. What is the difference between the Revenue generated (in %) in East Asia (developing only) in 2007 and the Revenue generated (in %) in Lebanon in 2008?
Ensure brevity in your answer.  -1.5. What is the difference between the Revenue generated (in %) of High income: OECD in 2007 and the Revenue generated (in %) of Low & middle income in 2008?
Give a very brief answer. -6.71. What is the difference between the Revenue generated (in %) in High income: OECD in 2007 and the Revenue generated (in %) in Lebanon in 2008?
Offer a terse response. -6.67. What is the difference between the Revenue generated (in %) in Low & middle income in 2007 and the Revenue generated (in %) in Lebanon in 2008?
Provide a succinct answer. 1.37. What is the difference between the Revenue generated (in %) of East Asia (developing only) in 2007 and the Revenue generated (in %) of High income: OECD in 2009?
Make the answer very short. 5.14. What is the difference between the Revenue generated (in %) of East Asia (developing only) in 2007 and the Revenue generated (in %) of Low & middle income in 2009?
Provide a succinct answer. -0.67. What is the difference between the Revenue generated (in %) in East Asia (developing only) in 2007 and the Revenue generated (in %) in Lebanon in 2009?
Provide a short and direct response. -1.04. What is the difference between the Revenue generated (in %) of High income: OECD in 2007 and the Revenue generated (in %) of Low & middle income in 2009?
Offer a terse response. -5.84. What is the difference between the Revenue generated (in %) of High income: OECD in 2007 and the Revenue generated (in %) of Lebanon in 2009?
Provide a succinct answer. -6.2. What is the difference between the Revenue generated (in %) in Low & middle income in 2007 and the Revenue generated (in %) in Lebanon in 2009?
Make the answer very short. 1.83. What is the difference between the Revenue generated (in %) in East Asia (developing only) in 2007 and the Revenue generated (in %) in High income: OECD in 2010?
Give a very brief answer. 5.05. What is the difference between the Revenue generated (in %) in East Asia (developing only) in 2007 and the Revenue generated (in %) in Low & middle income in 2010?
Ensure brevity in your answer.  -1.01. What is the difference between the Revenue generated (in %) in East Asia (developing only) in 2007 and the Revenue generated (in %) in Lebanon in 2010?
Your answer should be very brief. -1.51. What is the difference between the Revenue generated (in %) of High income: OECD in 2007 and the Revenue generated (in %) of Low & middle income in 2010?
Make the answer very short. -6.18. What is the difference between the Revenue generated (in %) in High income: OECD in 2007 and the Revenue generated (in %) in Lebanon in 2010?
Offer a terse response. -6.68. What is the difference between the Revenue generated (in %) in Low & middle income in 2007 and the Revenue generated (in %) in Lebanon in 2010?
Offer a very short reply. 1.36. What is the difference between the Revenue generated (in %) of East Asia (developing only) in 2007 and the Revenue generated (in %) of High income: OECD in 2011?
Your answer should be compact. 5.03. What is the difference between the Revenue generated (in %) of East Asia (developing only) in 2007 and the Revenue generated (in %) of Low & middle income in 2011?
Provide a short and direct response. -0.47. What is the difference between the Revenue generated (in %) in East Asia (developing only) in 2007 and the Revenue generated (in %) in Lebanon in 2011?
Your response must be concise. -0.47. What is the difference between the Revenue generated (in %) in High income: OECD in 2007 and the Revenue generated (in %) in Low & middle income in 2011?
Make the answer very short. -5.64. What is the difference between the Revenue generated (in %) of High income: OECD in 2007 and the Revenue generated (in %) of Lebanon in 2011?
Your response must be concise. -5.64. What is the difference between the Revenue generated (in %) in Low & middle income in 2007 and the Revenue generated (in %) in Lebanon in 2011?
Offer a terse response. 2.4. What is the difference between the Revenue generated (in %) in East Asia (developing only) in 2008 and the Revenue generated (in %) in High income: OECD in 2009?
Provide a short and direct response. 6.05. What is the difference between the Revenue generated (in %) of East Asia (developing only) in 2008 and the Revenue generated (in %) of Low & middle income in 2009?
Provide a short and direct response. 0.24. What is the difference between the Revenue generated (in %) in East Asia (developing only) in 2008 and the Revenue generated (in %) in Lebanon in 2009?
Make the answer very short. -0.13. What is the difference between the Revenue generated (in %) in High income: OECD in 2008 and the Revenue generated (in %) in Low & middle income in 2009?
Ensure brevity in your answer.  -5.79. What is the difference between the Revenue generated (in %) of High income: OECD in 2008 and the Revenue generated (in %) of Lebanon in 2009?
Provide a succinct answer. -6.15. What is the difference between the Revenue generated (in %) in Low & middle income in 2008 and the Revenue generated (in %) in Lebanon in 2009?
Your response must be concise. 0.5. What is the difference between the Revenue generated (in %) of East Asia (developing only) in 2008 and the Revenue generated (in %) of High income: OECD in 2010?
Your answer should be very brief. 5.96. What is the difference between the Revenue generated (in %) of East Asia (developing only) in 2008 and the Revenue generated (in %) of Low & middle income in 2010?
Keep it short and to the point. -0.1. What is the difference between the Revenue generated (in %) in East Asia (developing only) in 2008 and the Revenue generated (in %) in Lebanon in 2010?
Provide a short and direct response. -0.6. What is the difference between the Revenue generated (in %) in High income: OECD in 2008 and the Revenue generated (in %) in Low & middle income in 2010?
Offer a terse response. -6.13. What is the difference between the Revenue generated (in %) of High income: OECD in 2008 and the Revenue generated (in %) of Lebanon in 2010?
Keep it short and to the point. -6.63. What is the difference between the Revenue generated (in %) of Low & middle income in 2008 and the Revenue generated (in %) of Lebanon in 2010?
Your response must be concise. 0.03. What is the difference between the Revenue generated (in %) of East Asia (developing only) in 2008 and the Revenue generated (in %) of High income: OECD in 2011?
Your response must be concise. 5.94. What is the difference between the Revenue generated (in %) of East Asia (developing only) in 2008 and the Revenue generated (in %) of Low & middle income in 2011?
Keep it short and to the point. 0.44. What is the difference between the Revenue generated (in %) of East Asia (developing only) in 2008 and the Revenue generated (in %) of Lebanon in 2011?
Offer a very short reply. 0.44. What is the difference between the Revenue generated (in %) in High income: OECD in 2008 and the Revenue generated (in %) in Low & middle income in 2011?
Provide a succinct answer. -5.59. What is the difference between the Revenue generated (in %) in High income: OECD in 2008 and the Revenue generated (in %) in Lebanon in 2011?
Ensure brevity in your answer.  -5.59. What is the difference between the Revenue generated (in %) in Low & middle income in 2008 and the Revenue generated (in %) in Lebanon in 2011?
Keep it short and to the point. 1.07. What is the difference between the Revenue generated (in %) in East Asia (developing only) in 2009 and the Revenue generated (in %) in High income: OECD in 2010?
Offer a very short reply. 4.94. What is the difference between the Revenue generated (in %) in East Asia (developing only) in 2009 and the Revenue generated (in %) in Low & middle income in 2010?
Provide a succinct answer. -1.12. What is the difference between the Revenue generated (in %) in East Asia (developing only) in 2009 and the Revenue generated (in %) in Lebanon in 2010?
Make the answer very short. -1.61. What is the difference between the Revenue generated (in %) of High income: OECD in 2009 and the Revenue generated (in %) of Low & middle income in 2010?
Your answer should be compact. -6.15. What is the difference between the Revenue generated (in %) in High income: OECD in 2009 and the Revenue generated (in %) in Lebanon in 2010?
Make the answer very short. -6.65. What is the difference between the Revenue generated (in %) of Low & middle income in 2009 and the Revenue generated (in %) of Lebanon in 2010?
Provide a short and direct response. -0.84. What is the difference between the Revenue generated (in %) of East Asia (developing only) in 2009 and the Revenue generated (in %) of High income: OECD in 2011?
Your response must be concise. 4.93. What is the difference between the Revenue generated (in %) in East Asia (developing only) in 2009 and the Revenue generated (in %) in Low & middle income in 2011?
Your answer should be compact. -0.57. What is the difference between the Revenue generated (in %) of East Asia (developing only) in 2009 and the Revenue generated (in %) of Lebanon in 2011?
Provide a succinct answer. -0.57. What is the difference between the Revenue generated (in %) in High income: OECD in 2009 and the Revenue generated (in %) in Low & middle income in 2011?
Offer a terse response. -5.61. What is the difference between the Revenue generated (in %) of High income: OECD in 2009 and the Revenue generated (in %) of Lebanon in 2011?
Make the answer very short. -5.61. What is the difference between the Revenue generated (in %) in Low & middle income in 2009 and the Revenue generated (in %) in Lebanon in 2011?
Make the answer very short. 0.2. What is the difference between the Revenue generated (in %) in East Asia (developing only) in 2010 and the Revenue generated (in %) in High income: OECD in 2011?
Offer a terse response. 6.04. What is the difference between the Revenue generated (in %) in East Asia (developing only) in 2010 and the Revenue generated (in %) in Low & middle income in 2011?
Keep it short and to the point. 0.54. What is the difference between the Revenue generated (in %) of East Asia (developing only) in 2010 and the Revenue generated (in %) of Lebanon in 2011?
Offer a terse response. 0.54. What is the difference between the Revenue generated (in %) of High income: OECD in 2010 and the Revenue generated (in %) of Low & middle income in 2011?
Keep it short and to the point. -5.51. What is the difference between the Revenue generated (in %) in High income: OECD in 2010 and the Revenue generated (in %) in Lebanon in 2011?
Your response must be concise. -5.51. What is the difference between the Revenue generated (in %) of Low & middle income in 2010 and the Revenue generated (in %) of Lebanon in 2011?
Offer a terse response. 0.54. What is the average Revenue generated (in %) in East Asia (developing only) per year?
Your answer should be very brief. 6.14. What is the average Revenue generated (in %) of High income: OECD per year?
Your answer should be very brief. 0.3. What is the average Revenue generated (in %) of Low & middle income per year?
Provide a succinct answer. 7.41. What is the average Revenue generated (in %) of Lebanon per year?
Your answer should be very brief. 6.68. In the year 2004, what is the difference between the Revenue generated (in %) of East Asia (developing only) and Revenue generated (in %) of High income: OECD?
Your answer should be compact. 6.52. In the year 2004, what is the difference between the Revenue generated (in %) of East Asia (developing only) and Revenue generated (in %) of Low & middle income?
Your answer should be compact. -2.17. In the year 2004, what is the difference between the Revenue generated (in %) of East Asia (developing only) and Revenue generated (in %) of Lebanon?
Provide a succinct answer. -0.61. In the year 2004, what is the difference between the Revenue generated (in %) in High income: OECD and Revenue generated (in %) in Low & middle income?
Your answer should be compact. -8.69. In the year 2004, what is the difference between the Revenue generated (in %) in High income: OECD and Revenue generated (in %) in Lebanon?
Keep it short and to the point. -7.13. In the year 2004, what is the difference between the Revenue generated (in %) of Low & middle income and Revenue generated (in %) of Lebanon?
Offer a terse response. 1.56. In the year 2005, what is the difference between the Revenue generated (in %) of East Asia (developing only) and Revenue generated (in %) of High income: OECD?
Your response must be concise. 5.01. In the year 2005, what is the difference between the Revenue generated (in %) in East Asia (developing only) and Revenue generated (in %) in Low & middle income?
Keep it short and to the point. -3.38. In the year 2005, what is the difference between the Revenue generated (in %) of East Asia (developing only) and Revenue generated (in %) of Lebanon?
Your response must be concise. -1.87. In the year 2005, what is the difference between the Revenue generated (in %) in High income: OECD and Revenue generated (in %) in Low & middle income?
Give a very brief answer. -8.38. In the year 2005, what is the difference between the Revenue generated (in %) in High income: OECD and Revenue generated (in %) in Lebanon?
Offer a very short reply. -6.88. In the year 2005, what is the difference between the Revenue generated (in %) in Low & middle income and Revenue generated (in %) in Lebanon?
Your response must be concise. 1.5. In the year 2006, what is the difference between the Revenue generated (in %) in East Asia (developing only) and Revenue generated (in %) in High income: OECD?
Keep it short and to the point. 5.46. In the year 2006, what is the difference between the Revenue generated (in %) of East Asia (developing only) and Revenue generated (in %) of Low & middle income?
Your response must be concise. -2.26. In the year 2006, what is the difference between the Revenue generated (in %) in East Asia (developing only) and Revenue generated (in %) in Lebanon?
Your answer should be very brief. -0.31. In the year 2006, what is the difference between the Revenue generated (in %) in High income: OECD and Revenue generated (in %) in Low & middle income?
Your answer should be very brief. -7.72. In the year 2006, what is the difference between the Revenue generated (in %) in High income: OECD and Revenue generated (in %) in Lebanon?
Provide a short and direct response. -5.77. In the year 2006, what is the difference between the Revenue generated (in %) in Low & middle income and Revenue generated (in %) in Lebanon?
Make the answer very short. 1.95. In the year 2007, what is the difference between the Revenue generated (in %) of East Asia (developing only) and Revenue generated (in %) of High income: OECD?
Give a very brief answer. 5.17. In the year 2007, what is the difference between the Revenue generated (in %) in East Asia (developing only) and Revenue generated (in %) in Low & middle income?
Ensure brevity in your answer.  -2.87. In the year 2007, what is the difference between the Revenue generated (in %) of East Asia (developing only) and Revenue generated (in %) of Lebanon?
Give a very brief answer. -1.25. In the year 2007, what is the difference between the Revenue generated (in %) of High income: OECD and Revenue generated (in %) of Low & middle income?
Ensure brevity in your answer.  -8.04. In the year 2007, what is the difference between the Revenue generated (in %) of High income: OECD and Revenue generated (in %) of Lebanon?
Keep it short and to the point. -6.42. In the year 2007, what is the difference between the Revenue generated (in %) of Low & middle income and Revenue generated (in %) of Lebanon?
Make the answer very short. 1.62. In the year 2008, what is the difference between the Revenue generated (in %) in East Asia (developing only) and Revenue generated (in %) in High income: OECD?
Offer a very short reply. 6.03. In the year 2008, what is the difference between the Revenue generated (in %) in East Asia (developing only) and Revenue generated (in %) in Low & middle income?
Your answer should be very brief. -0.63. In the year 2008, what is the difference between the Revenue generated (in %) of East Asia (developing only) and Revenue generated (in %) of Lebanon?
Provide a short and direct response. -0.59. In the year 2008, what is the difference between the Revenue generated (in %) in High income: OECD and Revenue generated (in %) in Low & middle income?
Your answer should be very brief. -6.66. In the year 2008, what is the difference between the Revenue generated (in %) in High income: OECD and Revenue generated (in %) in Lebanon?
Your response must be concise. -6.62. In the year 2008, what is the difference between the Revenue generated (in %) of Low & middle income and Revenue generated (in %) of Lebanon?
Offer a terse response. 0.04. In the year 2009, what is the difference between the Revenue generated (in %) of East Asia (developing only) and Revenue generated (in %) of High income: OECD?
Provide a succinct answer. 5.04. In the year 2009, what is the difference between the Revenue generated (in %) in East Asia (developing only) and Revenue generated (in %) in Low & middle income?
Offer a terse response. -0.77. In the year 2009, what is the difference between the Revenue generated (in %) in East Asia (developing only) and Revenue generated (in %) in Lebanon?
Ensure brevity in your answer.  -1.14. In the year 2009, what is the difference between the Revenue generated (in %) of High income: OECD and Revenue generated (in %) of Low & middle income?
Keep it short and to the point. -5.81. In the year 2009, what is the difference between the Revenue generated (in %) in High income: OECD and Revenue generated (in %) in Lebanon?
Ensure brevity in your answer.  -6.18. In the year 2009, what is the difference between the Revenue generated (in %) of Low & middle income and Revenue generated (in %) of Lebanon?
Keep it short and to the point. -0.37. In the year 2010, what is the difference between the Revenue generated (in %) of East Asia (developing only) and Revenue generated (in %) of High income: OECD?
Your answer should be compact. 6.06. In the year 2010, what is the difference between the Revenue generated (in %) in East Asia (developing only) and Revenue generated (in %) in Low & middle income?
Provide a short and direct response. 0. In the year 2010, what is the difference between the Revenue generated (in %) of East Asia (developing only) and Revenue generated (in %) of Lebanon?
Offer a terse response. -0.5. In the year 2010, what is the difference between the Revenue generated (in %) in High income: OECD and Revenue generated (in %) in Low & middle income?
Offer a very short reply. -6.06. In the year 2010, what is the difference between the Revenue generated (in %) in High income: OECD and Revenue generated (in %) in Lebanon?
Your answer should be very brief. -6.55. In the year 2010, what is the difference between the Revenue generated (in %) in Low & middle income and Revenue generated (in %) in Lebanon?
Offer a terse response. -0.5. In the year 2011, what is the difference between the Revenue generated (in %) in East Asia (developing only) and Revenue generated (in %) in High income: OECD?
Make the answer very short. 7.43. In the year 2011, what is the difference between the Revenue generated (in %) in East Asia (developing only) and Revenue generated (in %) in Low & middle income?
Ensure brevity in your answer.  1.93. In the year 2011, what is the difference between the Revenue generated (in %) in East Asia (developing only) and Revenue generated (in %) in Lebanon?
Ensure brevity in your answer.  1.93. In the year 2011, what is the difference between the Revenue generated (in %) of High income: OECD and Revenue generated (in %) of Low & middle income?
Keep it short and to the point. -5.5. In the year 2011, what is the difference between the Revenue generated (in %) in High income: OECD and Revenue generated (in %) in Lebanon?
Provide a succinct answer. -5.5. In the year 2011, what is the difference between the Revenue generated (in %) in Low & middle income and Revenue generated (in %) in Lebanon?
Your response must be concise. 0. What is the ratio of the Revenue generated (in %) of East Asia (developing only) in 2004 to that in 2005?
Give a very brief answer. 1.35. What is the ratio of the Revenue generated (in %) of High income: OECD in 2004 to that in 2005?
Make the answer very short. 3.11. What is the ratio of the Revenue generated (in %) in Low & middle income in 2004 to that in 2005?
Provide a succinct answer. 1.07. What is the ratio of the Revenue generated (in %) in Lebanon in 2004 to that in 2005?
Offer a terse response. 1.08. What is the ratio of the Revenue generated (in %) in East Asia (developing only) in 2004 to that in 2006?
Ensure brevity in your answer.  1.24. What is the ratio of the Revenue generated (in %) in High income: OECD in 2004 to that in 2006?
Ensure brevity in your answer.  2.68. What is the ratio of the Revenue generated (in %) in Low & middle income in 2004 to that in 2006?
Keep it short and to the point. 1.16. What is the ratio of the Revenue generated (in %) of Lebanon in 2004 to that in 2006?
Provide a succinct answer. 1.28. What is the ratio of the Revenue generated (in %) in East Asia (developing only) in 2004 to that in 2007?
Give a very brief answer. 1.28. What is the ratio of the Revenue generated (in %) in High income: OECD in 2004 to that in 2007?
Your answer should be compact. 1.65. What is the ratio of the Revenue generated (in %) in Low & middle income in 2004 to that in 2007?
Offer a terse response. 1.1. What is the ratio of the Revenue generated (in %) in Lebanon in 2004 to that in 2007?
Your answer should be very brief. 1.13. What is the ratio of the Revenue generated (in %) of East Asia (developing only) in 2004 to that in 2008?
Offer a terse response. 1.1. What is the ratio of the Revenue generated (in %) in High income: OECD in 2004 to that in 2008?
Provide a short and direct response. 1.39. What is the ratio of the Revenue generated (in %) in Low & middle income in 2004 to that in 2008?
Make the answer very short. 1.31. What is the ratio of the Revenue generated (in %) of East Asia (developing only) in 2004 to that in 2009?
Provide a succinct answer. 1.3. What is the ratio of the Revenue generated (in %) of High income: OECD in 2004 to that in 2009?
Make the answer very short. 1.5. What is the ratio of the Revenue generated (in %) in Low & middle income in 2004 to that in 2009?
Your answer should be compact. 1.5. What is the ratio of the Revenue generated (in %) of Lebanon in 2004 to that in 2009?
Your response must be concise. 1.17. What is the ratio of the Revenue generated (in %) of East Asia (developing only) in 2004 to that in 2010?
Your response must be concise. 1.08. What is the ratio of the Revenue generated (in %) in High income: OECD in 2004 to that in 2010?
Offer a very short reply. 1.13. What is the ratio of the Revenue generated (in %) of Low & middle income in 2004 to that in 2010?
Provide a succinct answer. 1.42. What is the ratio of the Revenue generated (in %) in Lebanon in 2004 to that in 2010?
Provide a succinct answer. 1.09. What is the ratio of the Revenue generated (in %) of East Asia (developing only) in 2004 to that in 2011?
Keep it short and to the point. 0.89. What is the ratio of the Revenue generated (in %) of High income: OECD in 2004 to that in 2011?
Keep it short and to the point. 1.08. What is the ratio of the Revenue generated (in %) in Low & middle income in 2004 to that in 2011?
Ensure brevity in your answer.  1.55. What is the ratio of the Revenue generated (in %) of Lebanon in 2004 to that in 2011?
Provide a succinct answer. 1.28. What is the ratio of the Revenue generated (in %) of East Asia (developing only) in 2005 to that in 2006?
Ensure brevity in your answer.  0.92. What is the ratio of the Revenue generated (in %) of High income: OECD in 2005 to that in 2006?
Your answer should be compact. 0.86. What is the ratio of the Revenue generated (in %) in Low & middle income in 2005 to that in 2006?
Provide a short and direct response. 1.08. What is the ratio of the Revenue generated (in %) in Lebanon in 2005 to that in 2006?
Make the answer very short. 1.18. What is the ratio of the Revenue generated (in %) of East Asia (developing only) in 2005 to that in 2007?
Provide a short and direct response. 0.95. What is the ratio of the Revenue generated (in %) in High income: OECD in 2005 to that in 2007?
Ensure brevity in your answer.  0.53. What is the ratio of the Revenue generated (in %) of Low & middle income in 2005 to that in 2007?
Your answer should be compact. 1.03. What is the ratio of the Revenue generated (in %) of Lebanon in 2005 to that in 2007?
Your answer should be very brief. 1.05. What is the ratio of the Revenue generated (in %) of East Asia (developing only) in 2005 to that in 2008?
Keep it short and to the point. 0.81. What is the ratio of the Revenue generated (in %) in High income: OECD in 2005 to that in 2008?
Keep it short and to the point. 0.45. What is the ratio of the Revenue generated (in %) of Low & middle income in 2005 to that in 2008?
Keep it short and to the point. 1.22. What is the ratio of the Revenue generated (in %) of Lebanon in 2005 to that in 2008?
Your answer should be compact. 1.01. What is the ratio of the Revenue generated (in %) in East Asia (developing only) in 2005 to that in 2009?
Make the answer very short. 0.97. What is the ratio of the Revenue generated (in %) in High income: OECD in 2005 to that in 2009?
Offer a very short reply. 0.48. What is the ratio of the Revenue generated (in %) of Low & middle income in 2005 to that in 2009?
Your response must be concise. 1.4. What is the ratio of the Revenue generated (in %) of Lebanon in 2005 to that in 2009?
Give a very brief answer. 1.09. What is the ratio of the Revenue generated (in %) of East Asia (developing only) in 2005 to that in 2010?
Make the answer very short. 0.8. What is the ratio of the Revenue generated (in %) of High income: OECD in 2005 to that in 2010?
Offer a terse response. 0.36. What is the ratio of the Revenue generated (in %) of Low & middle income in 2005 to that in 2010?
Provide a short and direct response. 1.32. What is the ratio of the Revenue generated (in %) in Lebanon in 2005 to that in 2010?
Provide a succinct answer. 1.01. What is the ratio of the Revenue generated (in %) of East Asia (developing only) in 2005 to that in 2011?
Offer a very short reply. 0.66. What is the ratio of the Revenue generated (in %) of High income: OECD in 2005 to that in 2011?
Provide a succinct answer. 0.35. What is the ratio of the Revenue generated (in %) in Low & middle income in 2005 to that in 2011?
Your response must be concise. 1.44. What is the ratio of the Revenue generated (in %) in Lebanon in 2005 to that in 2011?
Offer a terse response. 1.19. What is the ratio of the Revenue generated (in %) of East Asia (developing only) in 2006 to that in 2007?
Give a very brief answer. 1.03. What is the ratio of the Revenue generated (in %) of High income: OECD in 2006 to that in 2007?
Your response must be concise. 0.62. What is the ratio of the Revenue generated (in %) in Low & middle income in 2006 to that in 2007?
Offer a very short reply. 0.95. What is the ratio of the Revenue generated (in %) of Lebanon in 2006 to that in 2007?
Provide a succinct answer. 0.89. What is the ratio of the Revenue generated (in %) in East Asia (developing only) in 2006 to that in 2008?
Your answer should be very brief. 0.89. What is the ratio of the Revenue generated (in %) of High income: OECD in 2006 to that in 2008?
Provide a succinct answer. 0.52. What is the ratio of the Revenue generated (in %) in Low & middle income in 2006 to that in 2008?
Your answer should be very brief. 1.13. What is the ratio of the Revenue generated (in %) of Lebanon in 2006 to that in 2008?
Make the answer very short. 0.85. What is the ratio of the Revenue generated (in %) of East Asia (developing only) in 2006 to that in 2009?
Make the answer very short. 1.05. What is the ratio of the Revenue generated (in %) in High income: OECD in 2006 to that in 2009?
Keep it short and to the point. 0.56. What is the ratio of the Revenue generated (in %) of Low & middle income in 2006 to that in 2009?
Give a very brief answer. 1.29. What is the ratio of the Revenue generated (in %) of Lebanon in 2006 to that in 2009?
Provide a succinct answer. 0.92. What is the ratio of the Revenue generated (in %) in East Asia (developing only) in 2006 to that in 2010?
Make the answer very short. 0.87. What is the ratio of the Revenue generated (in %) of High income: OECD in 2006 to that in 2010?
Give a very brief answer. 0.42. What is the ratio of the Revenue generated (in %) in Low & middle income in 2006 to that in 2010?
Make the answer very short. 1.22. What is the ratio of the Revenue generated (in %) in Lebanon in 2006 to that in 2010?
Offer a terse response. 0.85. What is the ratio of the Revenue generated (in %) in East Asia (developing only) in 2006 to that in 2011?
Your answer should be very brief. 0.72. What is the ratio of the Revenue generated (in %) in High income: OECD in 2006 to that in 2011?
Provide a succinct answer. 0.4. What is the ratio of the Revenue generated (in %) of Low & middle income in 2006 to that in 2011?
Make the answer very short. 1.34. What is the ratio of the Revenue generated (in %) in Lebanon in 2006 to that in 2011?
Your response must be concise. 1. What is the ratio of the Revenue generated (in %) of East Asia (developing only) in 2007 to that in 2008?
Your answer should be very brief. 0.86. What is the ratio of the Revenue generated (in %) in High income: OECD in 2007 to that in 2008?
Offer a terse response. 0.84. What is the ratio of the Revenue generated (in %) in Low & middle income in 2007 to that in 2008?
Make the answer very short. 1.19. What is the ratio of the Revenue generated (in %) of Lebanon in 2007 to that in 2008?
Your response must be concise. 0.96. What is the ratio of the Revenue generated (in %) in East Asia (developing only) in 2007 to that in 2009?
Provide a short and direct response. 1.02. What is the ratio of the Revenue generated (in %) of High income: OECD in 2007 to that in 2009?
Ensure brevity in your answer.  0.91. What is the ratio of the Revenue generated (in %) of Low & middle income in 2007 to that in 2009?
Provide a succinct answer. 1.36. What is the ratio of the Revenue generated (in %) in Lebanon in 2007 to that in 2009?
Provide a succinct answer. 1.03. What is the ratio of the Revenue generated (in %) in East Asia (developing only) in 2007 to that in 2010?
Offer a very short reply. 0.84. What is the ratio of the Revenue generated (in %) of High income: OECD in 2007 to that in 2010?
Your answer should be compact. 0.68. What is the ratio of the Revenue generated (in %) of Low & middle income in 2007 to that in 2010?
Offer a terse response. 1.29. What is the ratio of the Revenue generated (in %) of Lebanon in 2007 to that in 2010?
Offer a terse response. 0.96. What is the ratio of the Revenue generated (in %) of East Asia (developing only) in 2007 to that in 2011?
Provide a short and direct response. 0.69. What is the ratio of the Revenue generated (in %) in High income: OECD in 2007 to that in 2011?
Keep it short and to the point. 0.66. What is the ratio of the Revenue generated (in %) of Low & middle income in 2007 to that in 2011?
Provide a short and direct response. 1.41. What is the ratio of the Revenue generated (in %) in Lebanon in 2007 to that in 2011?
Offer a terse response. 1.13. What is the ratio of the Revenue generated (in %) of East Asia (developing only) in 2008 to that in 2009?
Your answer should be compact. 1.19. What is the ratio of the Revenue generated (in %) in High income: OECD in 2008 to that in 2009?
Provide a short and direct response. 1.08. What is the ratio of the Revenue generated (in %) in Lebanon in 2008 to that in 2009?
Provide a succinct answer. 1.07. What is the ratio of the Revenue generated (in %) in East Asia (developing only) in 2008 to that in 2010?
Offer a very short reply. 0.98. What is the ratio of the Revenue generated (in %) of High income: OECD in 2008 to that in 2010?
Your answer should be compact. 0.81. What is the ratio of the Revenue generated (in %) in Low & middle income in 2008 to that in 2010?
Offer a very short reply. 1.08. What is the ratio of the Revenue generated (in %) of East Asia (developing only) in 2008 to that in 2011?
Your answer should be compact. 0.81. What is the ratio of the Revenue generated (in %) of High income: OECD in 2008 to that in 2011?
Your answer should be very brief. 0.78. What is the ratio of the Revenue generated (in %) in Low & middle income in 2008 to that in 2011?
Offer a very short reply. 1.18. What is the ratio of the Revenue generated (in %) of Lebanon in 2008 to that in 2011?
Give a very brief answer. 1.18. What is the ratio of the Revenue generated (in %) of East Asia (developing only) in 2009 to that in 2010?
Make the answer very short. 0.83. What is the ratio of the Revenue generated (in %) of High income: OECD in 2009 to that in 2010?
Your answer should be very brief. 0.75. What is the ratio of the Revenue generated (in %) in Low & middle income in 2009 to that in 2010?
Keep it short and to the point. 0.95. What is the ratio of the Revenue generated (in %) in Lebanon in 2009 to that in 2010?
Give a very brief answer. 0.93. What is the ratio of the Revenue generated (in %) in East Asia (developing only) in 2009 to that in 2011?
Provide a succinct answer. 0.68. What is the ratio of the Revenue generated (in %) in High income: OECD in 2009 to that in 2011?
Your answer should be very brief. 0.72. What is the ratio of the Revenue generated (in %) of Low & middle income in 2009 to that in 2011?
Give a very brief answer. 1.03. What is the ratio of the Revenue generated (in %) in Lebanon in 2009 to that in 2011?
Ensure brevity in your answer.  1.1. What is the ratio of the Revenue generated (in %) in East Asia (developing only) in 2010 to that in 2011?
Offer a very short reply. 0.82. What is the ratio of the Revenue generated (in %) in High income: OECD in 2010 to that in 2011?
Keep it short and to the point. 0.96. What is the ratio of the Revenue generated (in %) in Low & middle income in 2010 to that in 2011?
Keep it short and to the point. 1.09. What is the ratio of the Revenue generated (in %) of Lebanon in 2010 to that in 2011?
Offer a very short reply. 1.18. What is the difference between the highest and the second highest Revenue generated (in %) in East Asia (developing only)?
Make the answer very short. 0.87. What is the difference between the highest and the second highest Revenue generated (in %) of High income: OECD?
Offer a very short reply. 0.03. What is the difference between the highest and the second highest Revenue generated (in %) in Low & middle income?
Provide a succinct answer. 0.6. What is the difference between the highest and the second highest Revenue generated (in %) in Lebanon?
Make the answer very short. 0.55. What is the difference between the highest and the lowest Revenue generated (in %) of East Asia (developing only)?
Offer a terse response. 2.68. What is the difference between the highest and the lowest Revenue generated (in %) of High income: OECD?
Offer a terse response. 0.3. What is the difference between the highest and the lowest Revenue generated (in %) of Low & middle income?
Keep it short and to the point. 3.22. What is the difference between the highest and the lowest Revenue generated (in %) of Lebanon?
Ensure brevity in your answer.  1.67. 